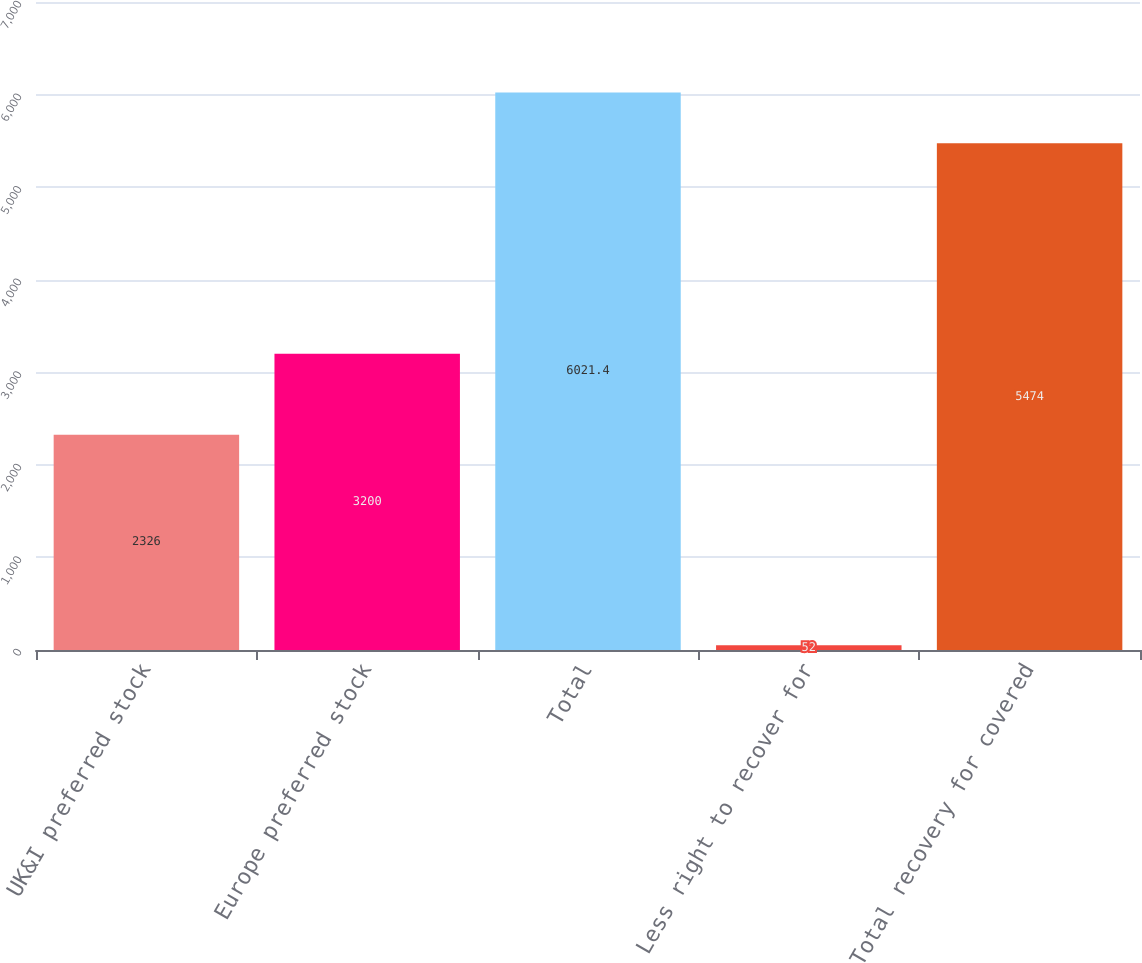Convert chart. <chart><loc_0><loc_0><loc_500><loc_500><bar_chart><fcel>UK&I preferred stock<fcel>Europe preferred stock<fcel>Total<fcel>Less right to recover for<fcel>Total recovery for covered<nl><fcel>2326<fcel>3200<fcel>6021.4<fcel>52<fcel>5474<nl></chart> 